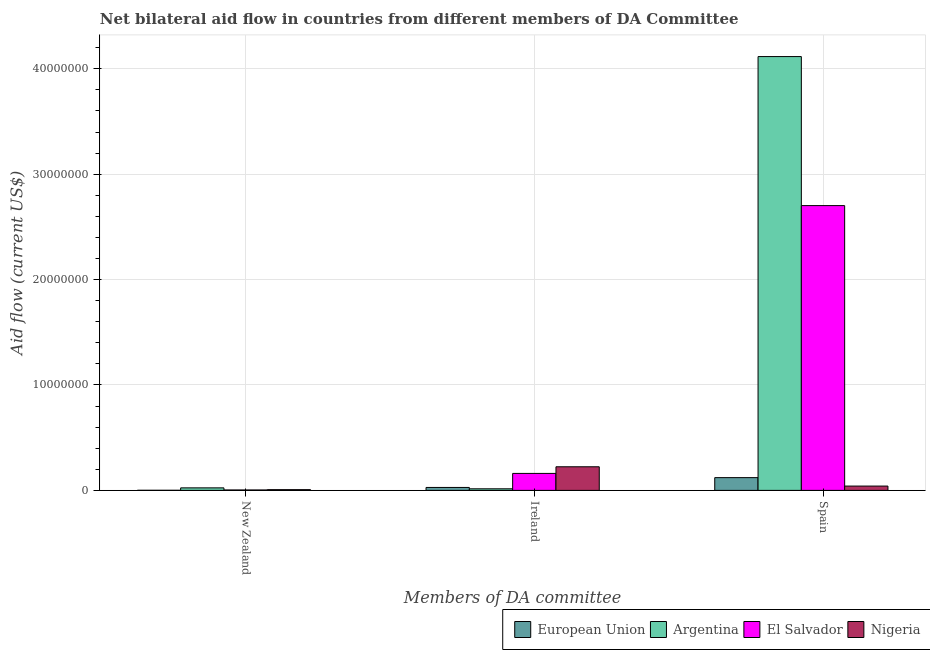Are the number of bars on each tick of the X-axis equal?
Keep it short and to the point. Yes. How many bars are there on the 3rd tick from the left?
Your answer should be very brief. 4. How many bars are there on the 3rd tick from the right?
Ensure brevity in your answer.  4. What is the label of the 1st group of bars from the left?
Ensure brevity in your answer.  New Zealand. What is the amount of aid provided by new zealand in El Salvador?
Keep it short and to the point. 4.00e+04. Across all countries, what is the maximum amount of aid provided by spain?
Provide a succinct answer. 4.12e+07. Across all countries, what is the minimum amount of aid provided by spain?
Your answer should be compact. 4.10e+05. In which country was the amount of aid provided by ireland maximum?
Provide a succinct answer. Nigeria. What is the total amount of aid provided by ireland in the graph?
Provide a succinct answer. 4.28e+06. What is the difference between the amount of aid provided by spain in European Union and that in Nigeria?
Make the answer very short. 8.00e+05. What is the difference between the amount of aid provided by new zealand in Argentina and the amount of aid provided by spain in European Union?
Your answer should be compact. -9.70e+05. What is the average amount of aid provided by ireland per country?
Keep it short and to the point. 1.07e+06. What is the difference between the amount of aid provided by ireland and amount of aid provided by new zealand in Nigeria?
Offer a very short reply. 2.17e+06. In how many countries, is the amount of aid provided by ireland greater than 28000000 US$?
Keep it short and to the point. 0. What is the ratio of the amount of aid provided by ireland in Nigeria to that in El Salvador?
Keep it short and to the point. 1.39. Is the amount of aid provided by ireland in European Union less than that in Nigeria?
Your answer should be compact. Yes. Is the difference between the amount of aid provided by new zealand in El Salvador and Argentina greater than the difference between the amount of aid provided by spain in El Salvador and Argentina?
Provide a short and direct response. Yes. What is the difference between the highest and the lowest amount of aid provided by spain?
Your answer should be very brief. 4.08e+07. In how many countries, is the amount of aid provided by new zealand greater than the average amount of aid provided by new zealand taken over all countries?
Your answer should be compact. 1. What does the 3rd bar from the left in New Zealand represents?
Give a very brief answer. El Salvador. Is it the case that in every country, the sum of the amount of aid provided by new zealand and amount of aid provided by ireland is greater than the amount of aid provided by spain?
Your response must be concise. No. How many bars are there?
Offer a very short reply. 12. Are all the bars in the graph horizontal?
Keep it short and to the point. No. Does the graph contain any zero values?
Give a very brief answer. No. Does the graph contain grids?
Your answer should be very brief. Yes. How are the legend labels stacked?
Keep it short and to the point. Horizontal. What is the title of the graph?
Offer a terse response. Net bilateral aid flow in countries from different members of DA Committee. What is the label or title of the X-axis?
Your answer should be very brief. Members of DA committee. What is the label or title of the Y-axis?
Your response must be concise. Aid flow (current US$). What is the Aid flow (current US$) in European Union in New Zealand?
Your response must be concise. 10000. What is the Aid flow (current US$) in Argentina in New Zealand?
Make the answer very short. 2.40e+05. What is the Aid flow (current US$) in Argentina in Ireland?
Your response must be concise. 1.50e+05. What is the Aid flow (current US$) of El Salvador in Ireland?
Provide a short and direct response. 1.61e+06. What is the Aid flow (current US$) of Nigeria in Ireland?
Give a very brief answer. 2.24e+06. What is the Aid flow (current US$) in European Union in Spain?
Your response must be concise. 1.21e+06. What is the Aid flow (current US$) of Argentina in Spain?
Give a very brief answer. 4.12e+07. What is the Aid flow (current US$) in El Salvador in Spain?
Provide a succinct answer. 2.70e+07. Across all Members of DA committee, what is the maximum Aid flow (current US$) in European Union?
Ensure brevity in your answer.  1.21e+06. Across all Members of DA committee, what is the maximum Aid flow (current US$) in Argentina?
Offer a very short reply. 4.12e+07. Across all Members of DA committee, what is the maximum Aid flow (current US$) of El Salvador?
Make the answer very short. 2.70e+07. Across all Members of DA committee, what is the maximum Aid flow (current US$) of Nigeria?
Provide a succinct answer. 2.24e+06. Across all Members of DA committee, what is the minimum Aid flow (current US$) in European Union?
Offer a terse response. 10000. What is the total Aid flow (current US$) in European Union in the graph?
Ensure brevity in your answer.  1.50e+06. What is the total Aid flow (current US$) in Argentina in the graph?
Offer a terse response. 4.16e+07. What is the total Aid flow (current US$) of El Salvador in the graph?
Ensure brevity in your answer.  2.87e+07. What is the total Aid flow (current US$) in Nigeria in the graph?
Your response must be concise. 2.72e+06. What is the difference between the Aid flow (current US$) of European Union in New Zealand and that in Ireland?
Ensure brevity in your answer.  -2.70e+05. What is the difference between the Aid flow (current US$) of Argentina in New Zealand and that in Ireland?
Provide a succinct answer. 9.00e+04. What is the difference between the Aid flow (current US$) in El Salvador in New Zealand and that in Ireland?
Make the answer very short. -1.57e+06. What is the difference between the Aid flow (current US$) of Nigeria in New Zealand and that in Ireland?
Provide a short and direct response. -2.17e+06. What is the difference between the Aid flow (current US$) of European Union in New Zealand and that in Spain?
Give a very brief answer. -1.20e+06. What is the difference between the Aid flow (current US$) in Argentina in New Zealand and that in Spain?
Keep it short and to the point. -4.09e+07. What is the difference between the Aid flow (current US$) of El Salvador in New Zealand and that in Spain?
Keep it short and to the point. -2.70e+07. What is the difference between the Aid flow (current US$) of Nigeria in New Zealand and that in Spain?
Your response must be concise. -3.40e+05. What is the difference between the Aid flow (current US$) in European Union in Ireland and that in Spain?
Offer a very short reply. -9.30e+05. What is the difference between the Aid flow (current US$) in Argentina in Ireland and that in Spain?
Offer a terse response. -4.10e+07. What is the difference between the Aid flow (current US$) in El Salvador in Ireland and that in Spain?
Offer a very short reply. -2.54e+07. What is the difference between the Aid flow (current US$) in Nigeria in Ireland and that in Spain?
Offer a terse response. 1.83e+06. What is the difference between the Aid flow (current US$) of European Union in New Zealand and the Aid flow (current US$) of El Salvador in Ireland?
Offer a terse response. -1.60e+06. What is the difference between the Aid flow (current US$) in European Union in New Zealand and the Aid flow (current US$) in Nigeria in Ireland?
Give a very brief answer. -2.23e+06. What is the difference between the Aid flow (current US$) of Argentina in New Zealand and the Aid flow (current US$) of El Salvador in Ireland?
Provide a succinct answer. -1.37e+06. What is the difference between the Aid flow (current US$) of Argentina in New Zealand and the Aid flow (current US$) of Nigeria in Ireland?
Offer a terse response. -2.00e+06. What is the difference between the Aid flow (current US$) of El Salvador in New Zealand and the Aid flow (current US$) of Nigeria in Ireland?
Keep it short and to the point. -2.20e+06. What is the difference between the Aid flow (current US$) of European Union in New Zealand and the Aid flow (current US$) of Argentina in Spain?
Make the answer very short. -4.12e+07. What is the difference between the Aid flow (current US$) of European Union in New Zealand and the Aid flow (current US$) of El Salvador in Spain?
Provide a succinct answer. -2.70e+07. What is the difference between the Aid flow (current US$) in European Union in New Zealand and the Aid flow (current US$) in Nigeria in Spain?
Your answer should be compact. -4.00e+05. What is the difference between the Aid flow (current US$) in Argentina in New Zealand and the Aid flow (current US$) in El Salvador in Spain?
Make the answer very short. -2.68e+07. What is the difference between the Aid flow (current US$) of Argentina in New Zealand and the Aid flow (current US$) of Nigeria in Spain?
Provide a succinct answer. -1.70e+05. What is the difference between the Aid flow (current US$) of El Salvador in New Zealand and the Aid flow (current US$) of Nigeria in Spain?
Make the answer very short. -3.70e+05. What is the difference between the Aid flow (current US$) in European Union in Ireland and the Aid flow (current US$) in Argentina in Spain?
Ensure brevity in your answer.  -4.09e+07. What is the difference between the Aid flow (current US$) in European Union in Ireland and the Aid flow (current US$) in El Salvador in Spain?
Offer a very short reply. -2.67e+07. What is the difference between the Aid flow (current US$) of Argentina in Ireland and the Aid flow (current US$) of El Salvador in Spain?
Keep it short and to the point. -2.69e+07. What is the difference between the Aid flow (current US$) in El Salvador in Ireland and the Aid flow (current US$) in Nigeria in Spain?
Provide a succinct answer. 1.20e+06. What is the average Aid flow (current US$) in European Union per Members of DA committee?
Your answer should be compact. 5.00e+05. What is the average Aid flow (current US$) in Argentina per Members of DA committee?
Keep it short and to the point. 1.38e+07. What is the average Aid flow (current US$) of El Salvador per Members of DA committee?
Offer a terse response. 9.56e+06. What is the average Aid flow (current US$) in Nigeria per Members of DA committee?
Ensure brevity in your answer.  9.07e+05. What is the difference between the Aid flow (current US$) of European Union and Aid flow (current US$) of Argentina in New Zealand?
Give a very brief answer. -2.30e+05. What is the difference between the Aid flow (current US$) of Argentina and Aid flow (current US$) of El Salvador in New Zealand?
Keep it short and to the point. 2.00e+05. What is the difference between the Aid flow (current US$) in Argentina and Aid flow (current US$) in Nigeria in New Zealand?
Provide a succinct answer. 1.70e+05. What is the difference between the Aid flow (current US$) in European Union and Aid flow (current US$) in Argentina in Ireland?
Make the answer very short. 1.30e+05. What is the difference between the Aid flow (current US$) in European Union and Aid flow (current US$) in El Salvador in Ireland?
Ensure brevity in your answer.  -1.33e+06. What is the difference between the Aid flow (current US$) in European Union and Aid flow (current US$) in Nigeria in Ireland?
Your answer should be very brief. -1.96e+06. What is the difference between the Aid flow (current US$) of Argentina and Aid flow (current US$) of El Salvador in Ireland?
Provide a succinct answer. -1.46e+06. What is the difference between the Aid flow (current US$) in Argentina and Aid flow (current US$) in Nigeria in Ireland?
Your answer should be very brief. -2.09e+06. What is the difference between the Aid flow (current US$) of El Salvador and Aid flow (current US$) of Nigeria in Ireland?
Give a very brief answer. -6.30e+05. What is the difference between the Aid flow (current US$) of European Union and Aid flow (current US$) of Argentina in Spain?
Your answer should be very brief. -4.00e+07. What is the difference between the Aid flow (current US$) of European Union and Aid flow (current US$) of El Salvador in Spain?
Provide a succinct answer. -2.58e+07. What is the difference between the Aid flow (current US$) in Argentina and Aid flow (current US$) in El Salvador in Spain?
Keep it short and to the point. 1.41e+07. What is the difference between the Aid flow (current US$) in Argentina and Aid flow (current US$) in Nigeria in Spain?
Provide a succinct answer. 4.08e+07. What is the difference between the Aid flow (current US$) of El Salvador and Aid flow (current US$) of Nigeria in Spain?
Provide a succinct answer. 2.66e+07. What is the ratio of the Aid flow (current US$) in European Union in New Zealand to that in Ireland?
Your response must be concise. 0.04. What is the ratio of the Aid flow (current US$) of El Salvador in New Zealand to that in Ireland?
Offer a terse response. 0.02. What is the ratio of the Aid flow (current US$) of Nigeria in New Zealand to that in Ireland?
Offer a very short reply. 0.03. What is the ratio of the Aid flow (current US$) of European Union in New Zealand to that in Spain?
Your response must be concise. 0.01. What is the ratio of the Aid flow (current US$) in Argentina in New Zealand to that in Spain?
Your answer should be very brief. 0.01. What is the ratio of the Aid flow (current US$) in El Salvador in New Zealand to that in Spain?
Offer a terse response. 0. What is the ratio of the Aid flow (current US$) in Nigeria in New Zealand to that in Spain?
Give a very brief answer. 0.17. What is the ratio of the Aid flow (current US$) in European Union in Ireland to that in Spain?
Make the answer very short. 0.23. What is the ratio of the Aid flow (current US$) in Argentina in Ireland to that in Spain?
Provide a short and direct response. 0. What is the ratio of the Aid flow (current US$) of El Salvador in Ireland to that in Spain?
Offer a very short reply. 0.06. What is the ratio of the Aid flow (current US$) in Nigeria in Ireland to that in Spain?
Provide a short and direct response. 5.46. What is the difference between the highest and the second highest Aid flow (current US$) in European Union?
Your answer should be compact. 9.30e+05. What is the difference between the highest and the second highest Aid flow (current US$) of Argentina?
Give a very brief answer. 4.09e+07. What is the difference between the highest and the second highest Aid flow (current US$) in El Salvador?
Your answer should be compact. 2.54e+07. What is the difference between the highest and the second highest Aid flow (current US$) in Nigeria?
Your response must be concise. 1.83e+06. What is the difference between the highest and the lowest Aid flow (current US$) in European Union?
Your answer should be very brief. 1.20e+06. What is the difference between the highest and the lowest Aid flow (current US$) of Argentina?
Make the answer very short. 4.10e+07. What is the difference between the highest and the lowest Aid flow (current US$) of El Salvador?
Offer a very short reply. 2.70e+07. What is the difference between the highest and the lowest Aid flow (current US$) in Nigeria?
Keep it short and to the point. 2.17e+06. 